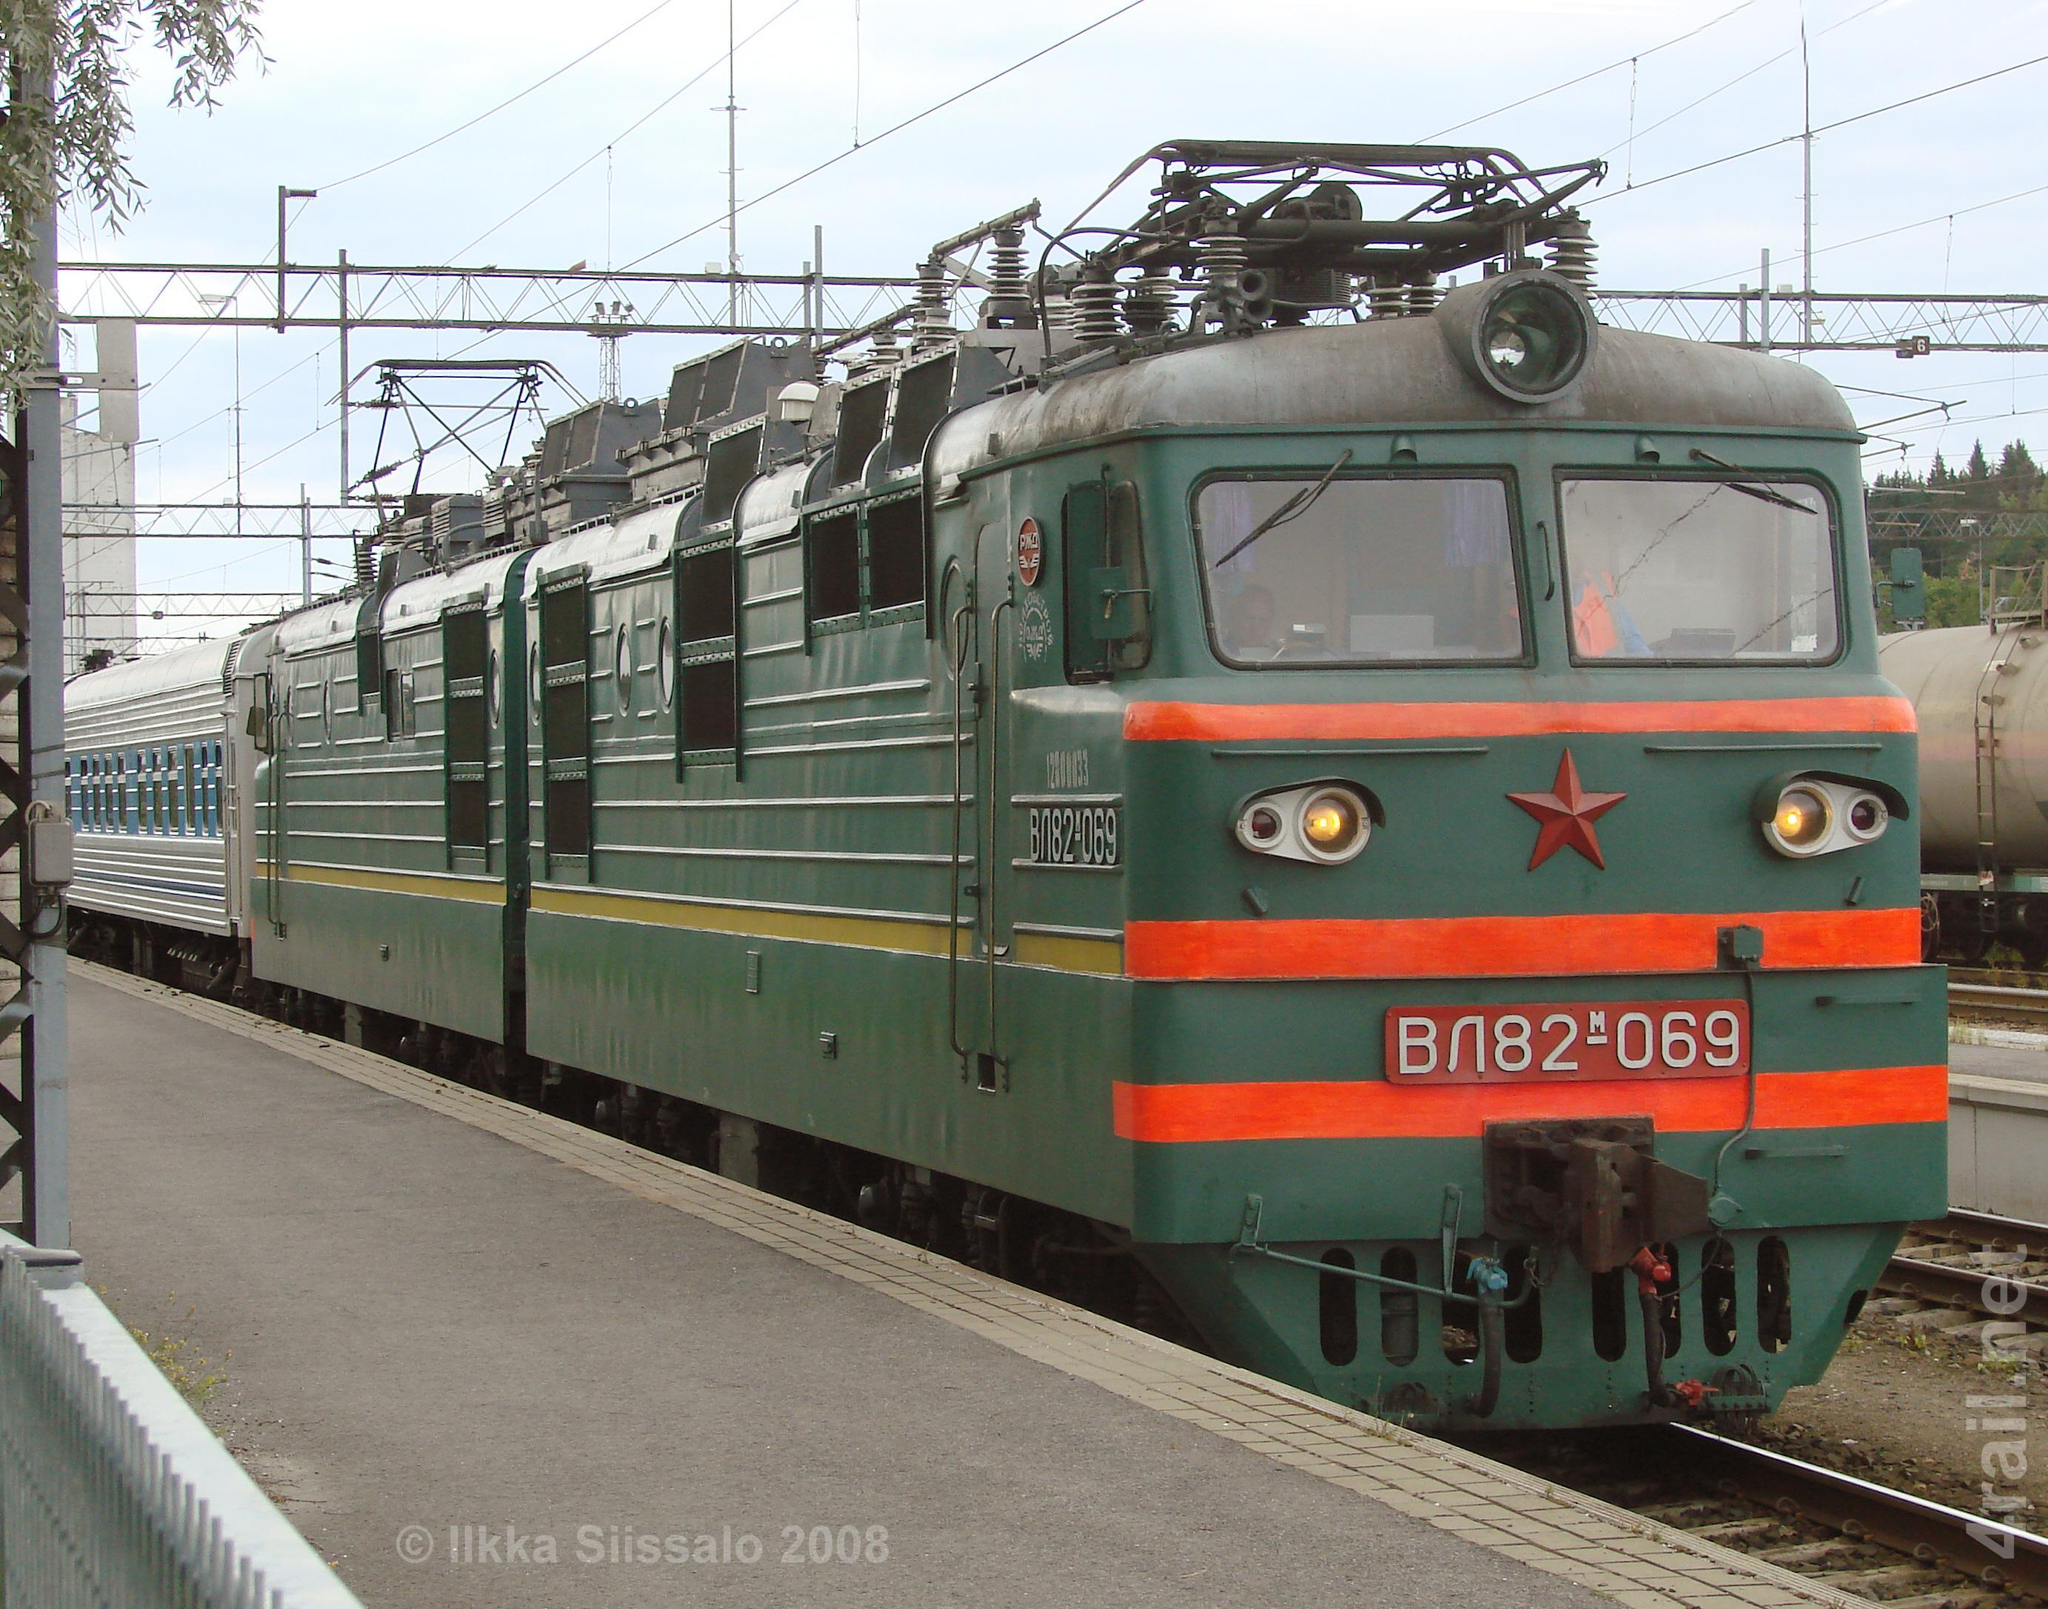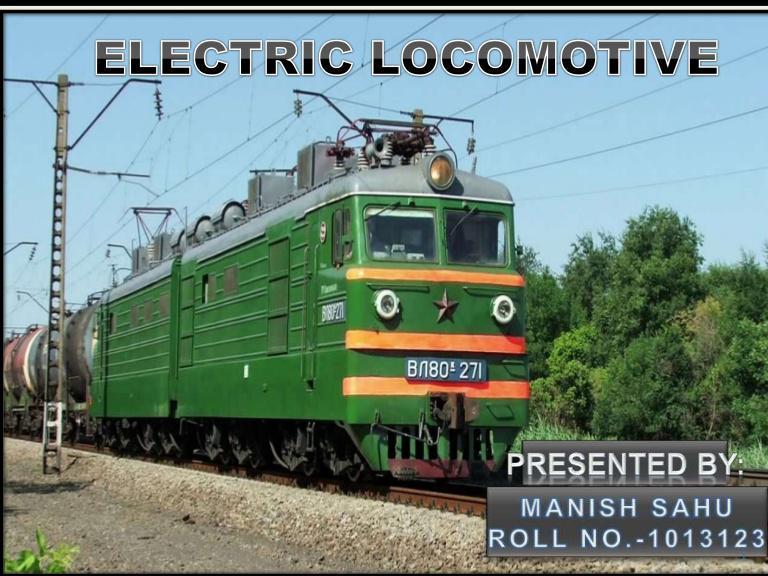The first image is the image on the left, the second image is the image on the right. Assess this claim about the two images: "Both trains are primarily green and moving toward the right.". Correct or not? Answer yes or no. Yes. The first image is the image on the left, the second image is the image on the right. Given the left and right images, does the statement "All trains are greenish in color and heading rightward at an angle." hold true? Answer yes or no. Yes. 